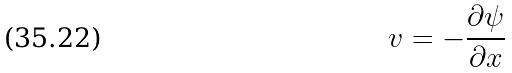<formula> <loc_0><loc_0><loc_500><loc_500>v = - \frac { \partial \psi } { \partial x }</formula> 